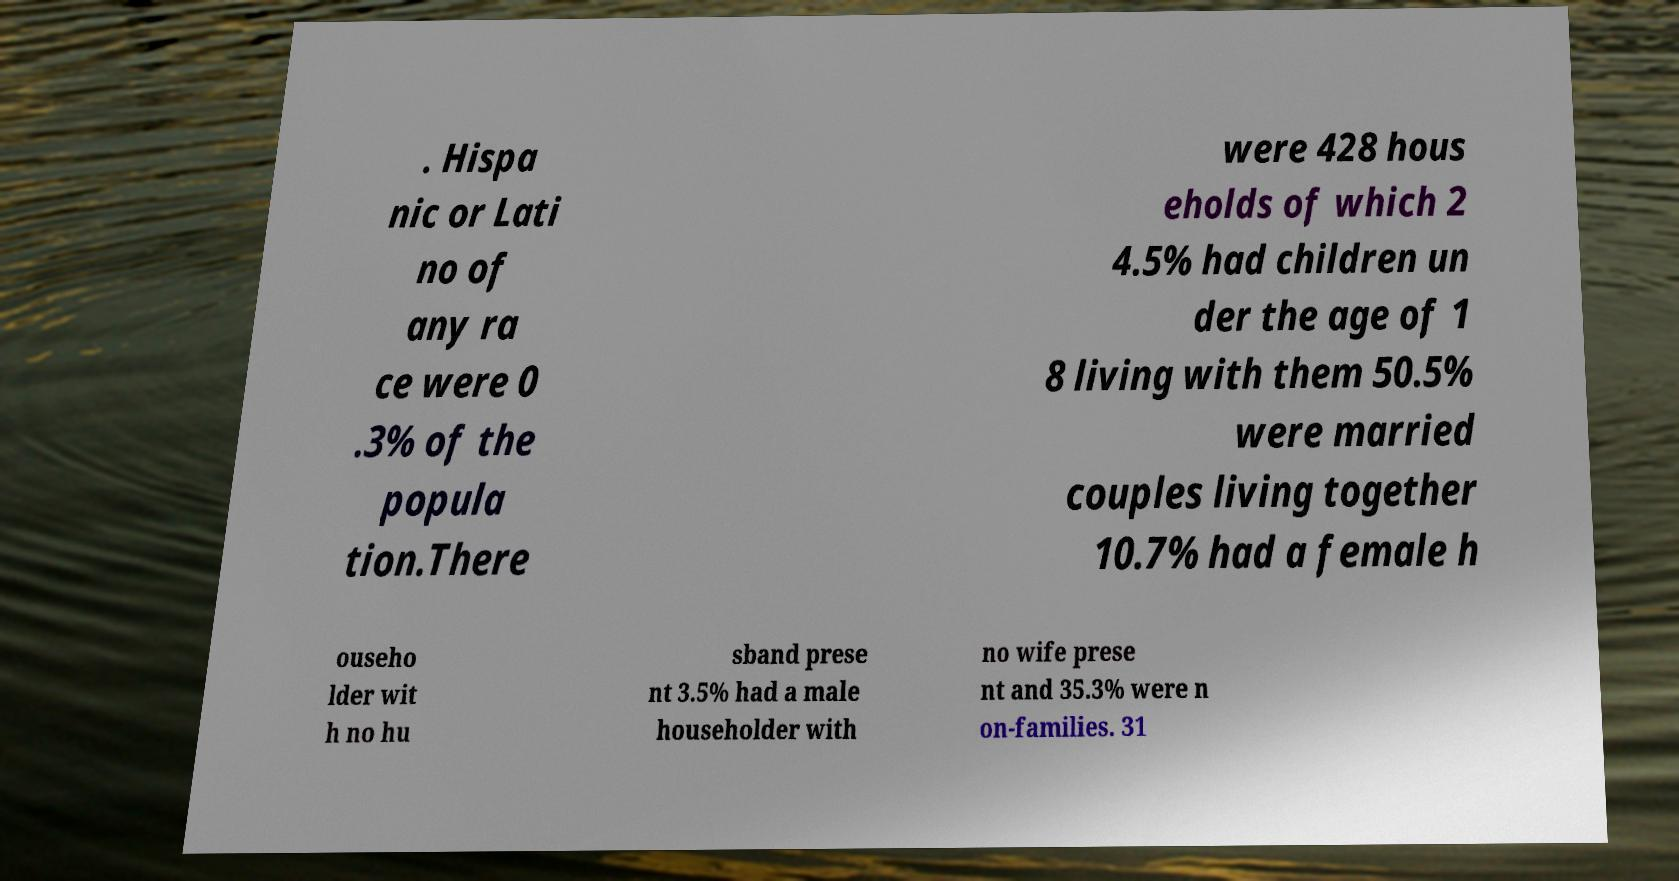Please read and relay the text visible in this image. What does it say? . Hispa nic or Lati no of any ra ce were 0 .3% of the popula tion.There were 428 hous eholds of which 2 4.5% had children un der the age of 1 8 living with them 50.5% were married couples living together 10.7% had a female h ouseho lder wit h no hu sband prese nt 3.5% had a male householder with no wife prese nt and 35.3% were n on-families. 31 